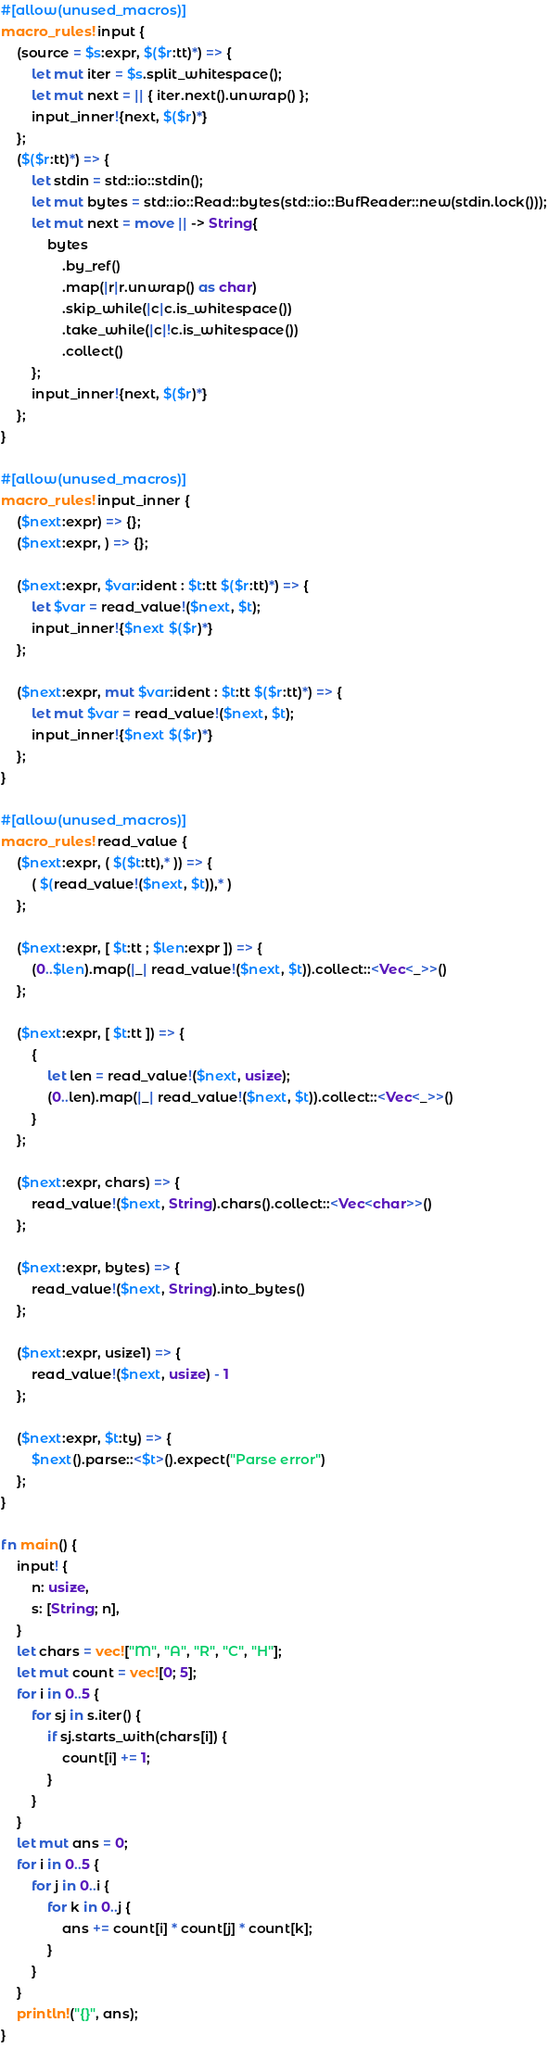Convert code to text. <code><loc_0><loc_0><loc_500><loc_500><_Rust_>#[allow(unused_macros)]
macro_rules! input {
    (source = $s:expr, $($r:tt)*) => {
        let mut iter = $s.split_whitespace();
        let mut next = || { iter.next().unwrap() };
        input_inner!{next, $($r)*}
    };
    ($($r:tt)*) => {
        let stdin = std::io::stdin();
        let mut bytes = std::io::Read::bytes(std::io::BufReader::new(stdin.lock()));
        let mut next = move || -> String{
            bytes
                .by_ref()
                .map(|r|r.unwrap() as char)
                .skip_while(|c|c.is_whitespace())
                .take_while(|c|!c.is_whitespace())
                .collect()
        };
        input_inner!{next, $($r)*}
    };
}

#[allow(unused_macros)]
macro_rules! input_inner {
    ($next:expr) => {};
    ($next:expr, ) => {};

    ($next:expr, $var:ident : $t:tt $($r:tt)*) => {
        let $var = read_value!($next, $t);
        input_inner!{$next $($r)*}
    };

    ($next:expr, mut $var:ident : $t:tt $($r:tt)*) => {
        let mut $var = read_value!($next, $t);
        input_inner!{$next $($r)*}
    };
}

#[allow(unused_macros)]
macro_rules! read_value {
    ($next:expr, ( $($t:tt),* )) => {
        ( $(read_value!($next, $t)),* )
    };

    ($next:expr, [ $t:tt ; $len:expr ]) => {
        (0..$len).map(|_| read_value!($next, $t)).collect::<Vec<_>>()
    };

    ($next:expr, [ $t:tt ]) => {
        {
            let len = read_value!($next, usize);
            (0..len).map(|_| read_value!($next, $t)).collect::<Vec<_>>()
        }
    };

    ($next:expr, chars) => {
        read_value!($next, String).chars().collect::<Vec<char>>()
    };

    ($next:expr, bytes) => {
        read_value!($next, String).into_bytes()
    };

    ($next:expr, usize1) => {
        read_value!($next, usize) - 1
    };

    ($next:expr, $t:ty) => {
        $next().parse::<$t>().expect("Parse error")
    };
}

fn main() {
    input! {
        n: usize,
        s: [String; n],
    }
    let chars = vec!["M", "A", "R", "C", "H"];
    let mut count = vec![0; 5];
    for i in 0..5 {
        for sj in s.iter() {
            if sj.starts_with(chars[i]) {
                count[i] += 1;
            }
        }
    }
    let mut ans = 0;
    for i in 0..5 {
        for j in 0..i {
            for k in 0..j {
                ans += count[i] * count[j] * count[k];
            }
        }
    }
    println!("{}", ans);
}
</code> 